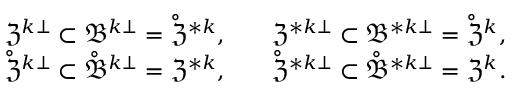Convert formula to latex. <formula><loc_0><loc_0><loc_500><loc_500>\begin{array} { r l r } & { \mathfrak { Z } ^ { k \bot } \subset \mathfrak { B } ^ { k \bot } = \mathring { \mathfrak { Z } } ^ { \ast k } , \quad } & { \mathfrak { Z } ^ { \ast k \bot } \subset \mathfrak { B } ^ { \ast k \bot } = \mathring { \mathfrak { Z } } ^ { k } , } \\ & { \mathring { \mathfrak { Z } } ^ { k \bot } \subset \mathring { \mathfrak { B } } ^ { k \bot } = \mathfrak { Z } ^ { \ast k } , \quad } & { \mathring { \mathfrak { Z } } ^ { \ast k \bot } \subset \mathring { \mathfrak { B } } ^ { \ast k \bot } = \mathfrak { Z } ^ { k } . } \end{array}</formula> 